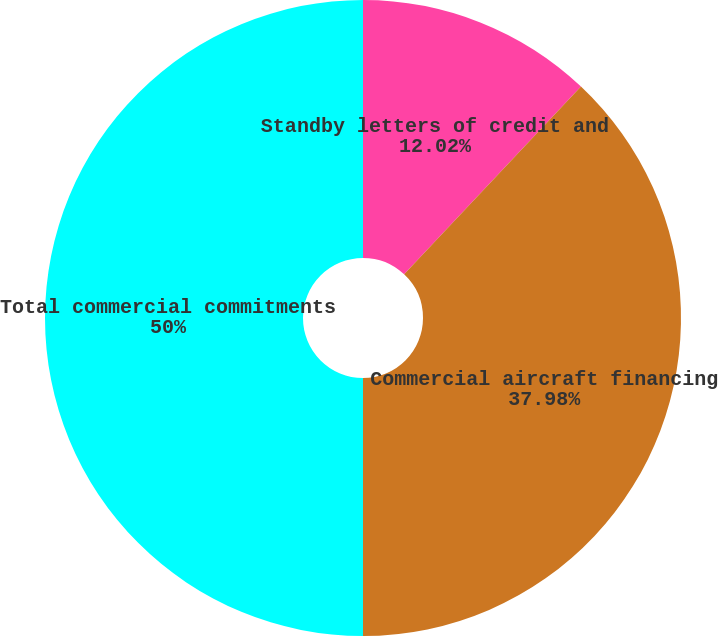Convert chart. <chart><loc_0><loc_0><loc_500><loc_500><pie_chart><fcel>Standby letters of credit and<fcel>Commercial aircraft financing<fcel>Total commercial commitments<nl><fcel>12.02%<fcel>37.98%<fcel>50.0%<nl></chart> 